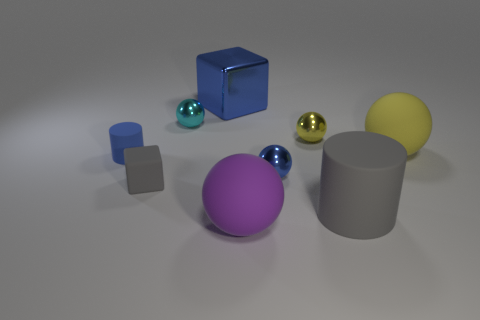Subtract all green cubes. How many yellow spheres are left? 2 Subtract all large yellow spheres. How many spheres are left? 4 Subtract all yellow balls. How many balls are left? 3 Add 1 blue metal spheres. How many objects exist? 10 Subtract all blue spheres. Subtract all yellow cylinders. How many spheres are left? 4 Subtract all spheres. How many objects are left? 4 Subtract all tiny metallic objects. Subtract all tiny spheres. How many objects are left? 3 Add 7 yellow metal spheres. How many yellow metal spheres are left? 8 Add 4 gray blocks. How many gray blocks exist? 5 Subtract 0 purple blocks. How many objects are left? 9 